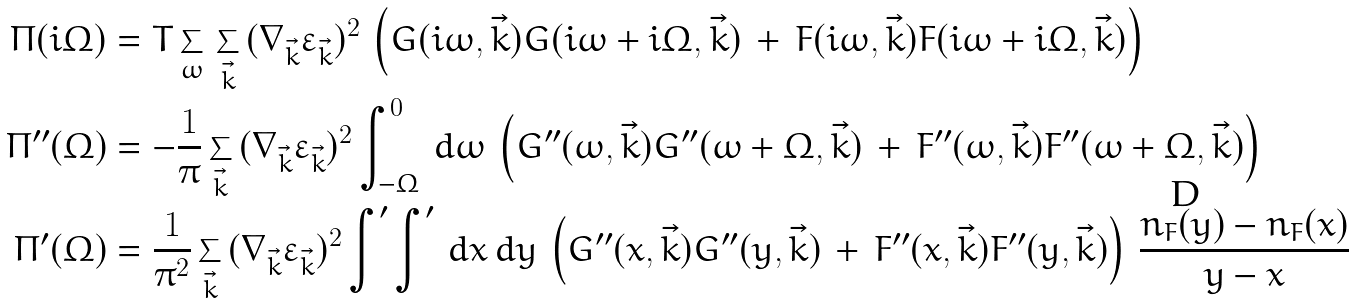<formula> <loc_0><loc_0><loc_500><loc_500>\Pi ( i \Omega ) & = T \sum _ { \omega } \, \sum _ { \vec { k } } \, ( \nabla _ { \vec { k } } \varepsilon _ { \vec { k } } ) ^ { 2 } \, \left ( G ( i \omega , \vec { k } ) G ( i \omega + i \Omega , \vec { k } ) \, + \, F ( i \omega , \vec { k } ) F ( i \omega + i \Omega , \vec { k } ) \right ) \\ \Pi ^ { \prime \prime } ( \Omega ) & = - \frac { 1 } { \pi } \sum _ { \vec { k } } \, ( \nabla _ { \vec { k } } \varepsilon _ { \vec { k } } ) ^ { 2 } \int ^ { 0 } _ { - \Omega } \, d \omega \, \left ( G ^ { \prime \prime } ( \omega , \vec { k } ) G ^ { \prime \prime } ( \omega + \Omega , \vec { k } ) \, + \, F ^ { \prime \prime } ( \omega , \vec { k } ) F ^ { \prime \prime } ( \omega + \Omega , \vec { k } ) \right ) \\ \Pi ^ { \prime } ( \Omega ) & = \frac { 1 } { \pi ^ { 2 } } \sum _ { \vec { k } } \, ( \nabla _ { \vec { k } } \varepsilon _ { \vec { k } } ) ^ { 2 } \int ^ { \prime } \int ^ { \prime } \, d x \, d y \, \left ( G ^ { \prime \prime } ( x , \vec { k } ) G ^ { \prime \prime } ( y , \vec { k } ) \, + \, F ^ { \prime \prime } ( x , \vec { k } ) F ^ { \prime \prime } ( y , \vec { k } ) \right ) \, \frac { n _ { F } ( y ) - n _ { F } ( x ) } { y - x }</formula> 